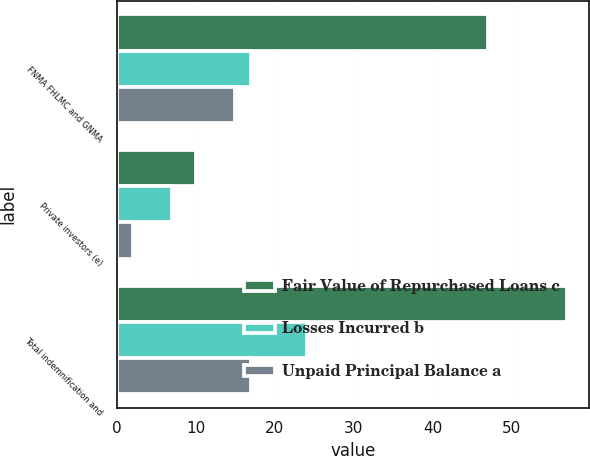<chart> <loc_0><loc_0><loc_500><loc_500><stacked_bar_chart><ecel><fcel>FNMA FHLMC and GNMA<fcel>Private investors (e)<fcel>Total indemnification and<nl><fcel>Fair Value of Repurchased Loans c<fcel>47<fcel>10<fcel>57<nl><fcel>Losses Incurred b<fcel>17<fcel>7<fcel>24<nl><fcel>Unpaid Principal Balance a<fcel>15<fcel>2<fcel>17<nl></chart> 